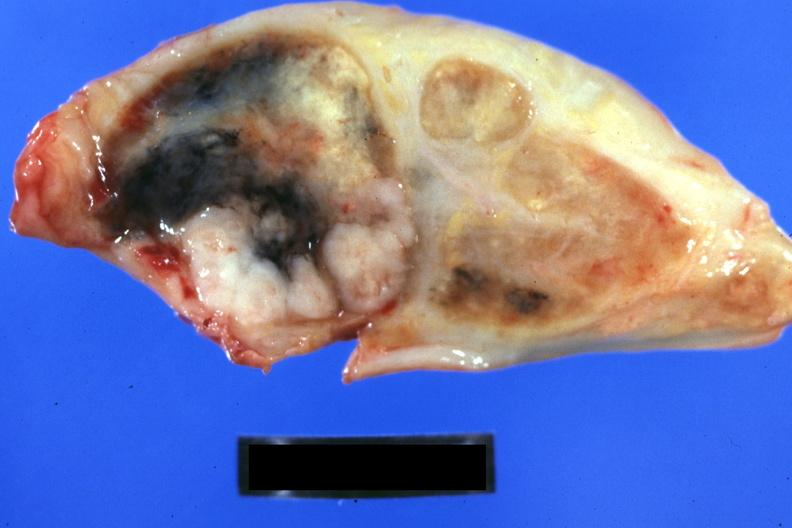s lymph node present?
Answer the question using a single word or phrase. Yes 